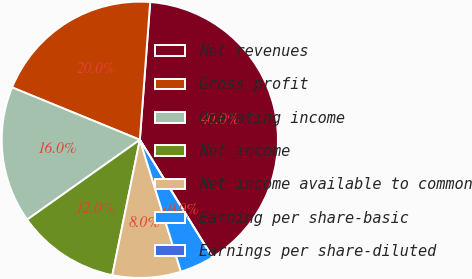Convert chart to OTSL. <chart><loc_0><loc_0><loc_500><loc_500><pie_chart><fcel>Net revenues<fcel>Gross profit<fcel>Operating income<fcel>Net income<fcel>Net income available to common<fcel>Earning per share-basic<fcel>Earnings per share-diluted<nl><fcel>40.0%<fcel>20.0%<fcel>16.0%<fcel>12.0%<fcel>8.0%<fcel>4.0%<fcel>0.0%<nl></chart> 